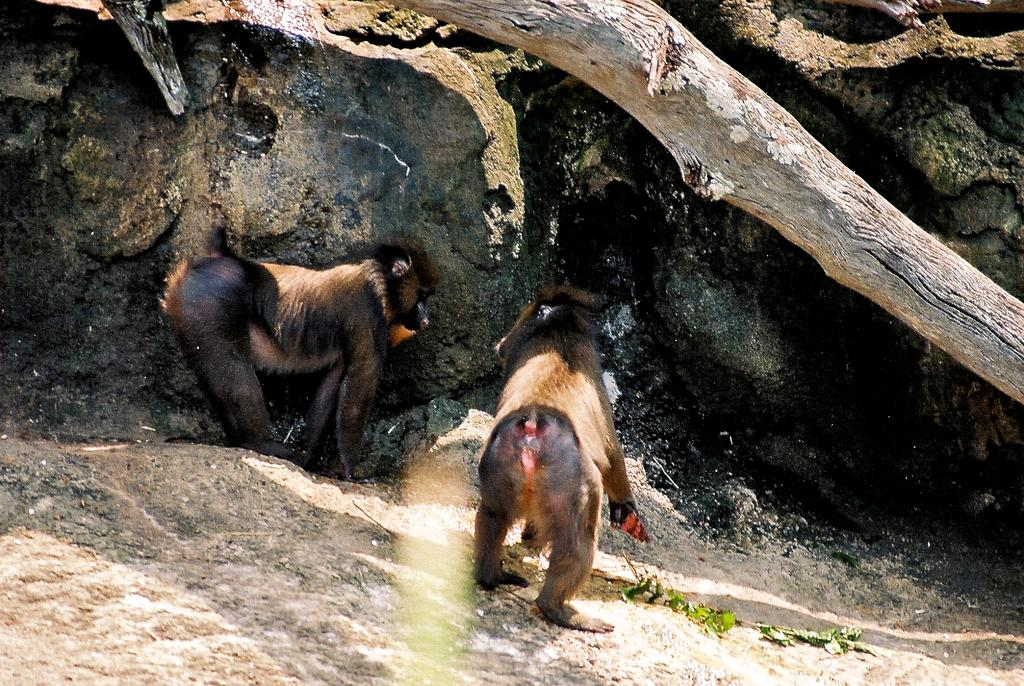How many animals are present in the image? There are two animals in the image. What is the location of the animals in the image? The animals are near a rock wall. What type of vegetation can be seen on the ground in the image? There is a branch with green leaves on the ground in the image. What is the condition of the tree branch at the top of the image? There is a dried tree branch at the top of the image. What language are the animals speaking to each other in the image? Animals do not speak human languages, so there is no language spoken between them in the image. 